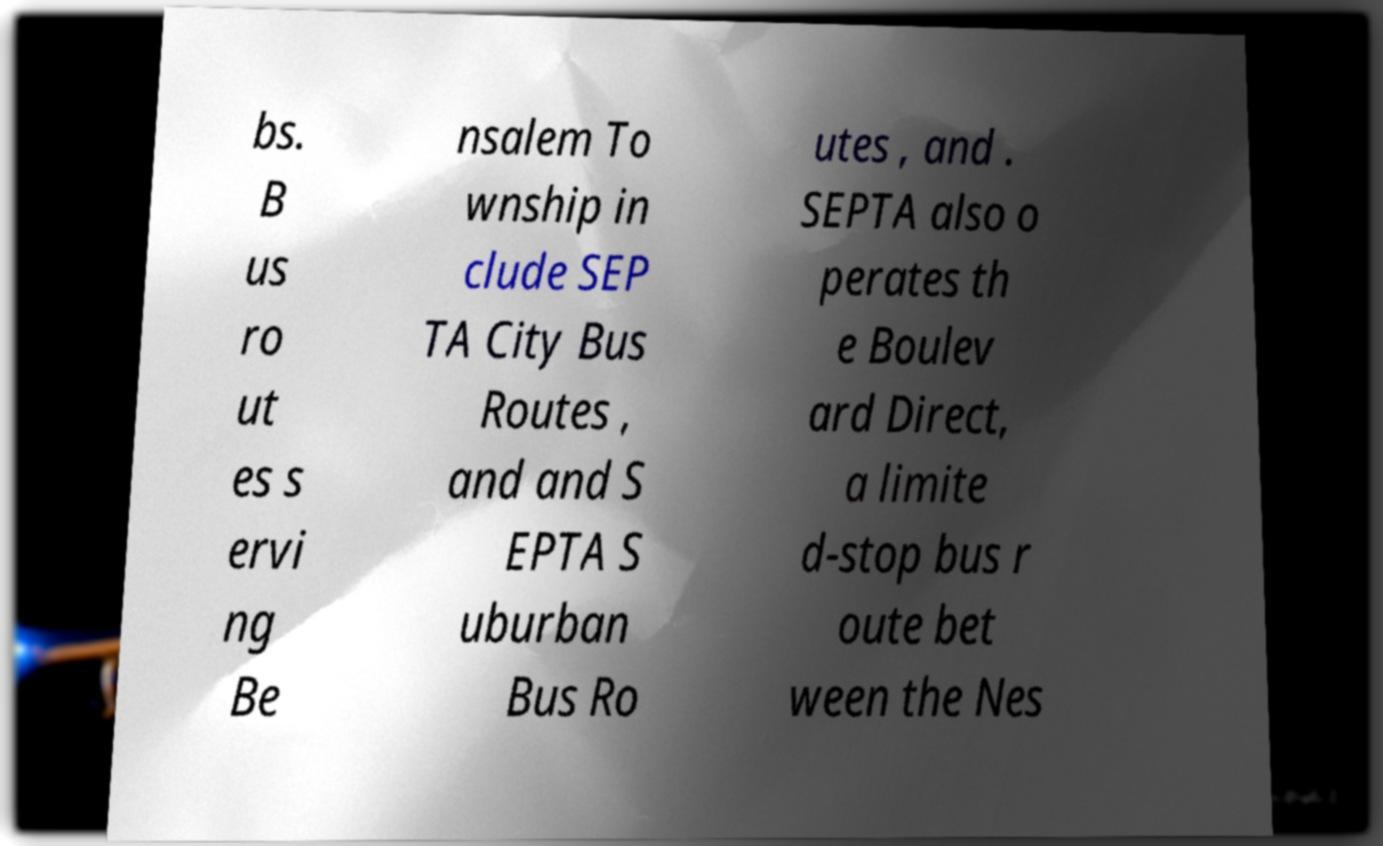Please identify and transcribe the text found in this image. bs. B us ro ut es s ervi ng Be nsalem To wnship in clude SEP TA City Bus Routes , and and S EPTA S uburban Bus Ro utes , and . SEPTA also o perates th e Boulev ard Direct, a limite d-stop bus r oute bet ween the Nes 